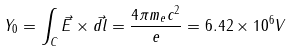Convert formula to latex. <formula><loc_0><loc_0><loc_500><loc_500>Y _ { 0 } = \int _ { C } \vec { E } \times \vec { d l } = \frac { 4 \pi m _ { e } c ^ { 2 } } { e } = 6 . 4 2 \times 1 0 ^ { 6 } V</formula> 